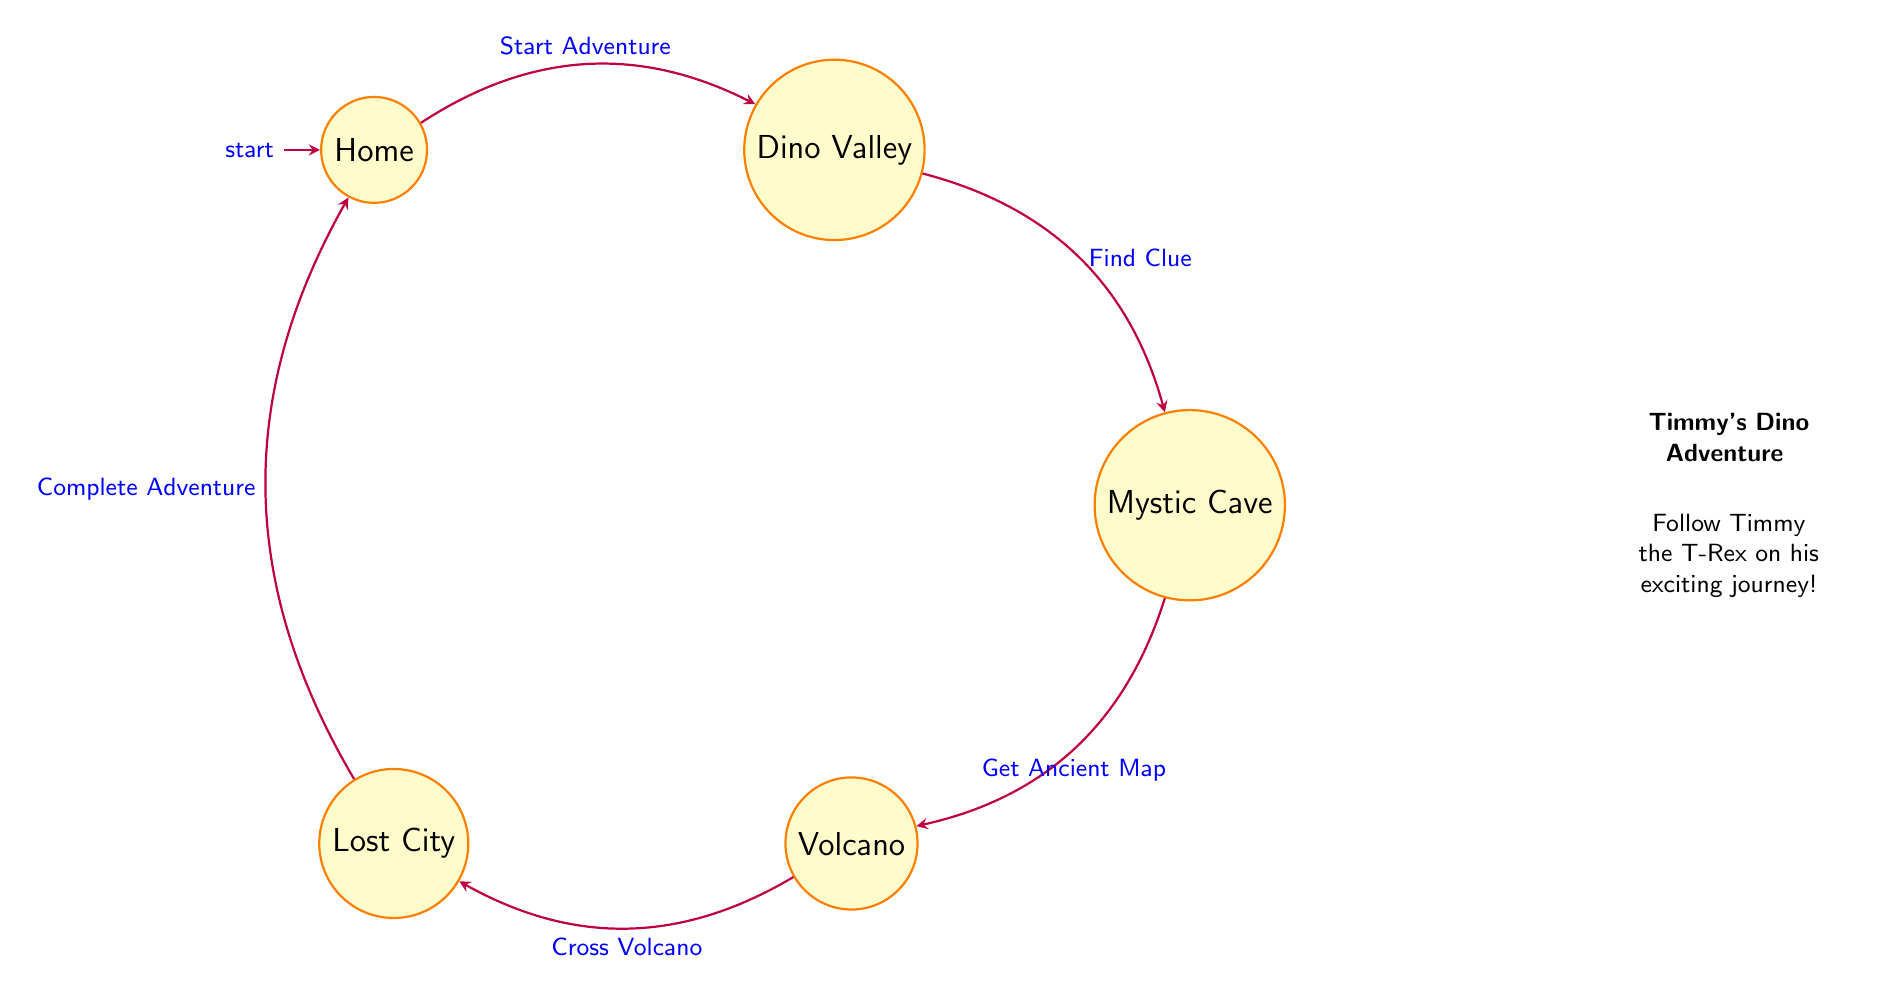What is the first state in Timmy's adventure? The diagram starts with the "Home" state as the initial node where the adventure begins.
Answer: Home How many states are in Timmy's adventure? By counting the nodes in the diagram, we find there are five states: Home, Dino Valley, Mystic Cave, Volcano, and Lost City.
Answer: 5 What action occurs when transitioning from Dino Valley? Looking at the transition from Dino Valley, the action "Find Clue" is listed as the trigger that leads to Mystic Cave.
Answer: Find Clue What is the final state in the adventure? The diagram shows that the last state before returning to the start (Home) is the Lost City.
Answer: Lost City What action must Timmy take to cross the Volcano? In the transition from the Volcano state, the action needed is "Cross Volcano" to proceed to Lost City.
Answer: Cross Volcano Which two states are directly connected by the action "Get Ancient Map"? The action connects Mystic Cave and Volcano, making them the two states related by that action.
Answer: Mystic Cave, Volcano How many transitions are there in total across the adventure? By counting the connections (arrows) between the states, we see there are four transitions: Home to Dino Valley, Dino Valley to Mystic Cave, Mystic Cave to Volcano, and Volcano to Lost City.
Answer: 4 What must happen after discovering the ruins in the Lost City? After the adventure in the Lost City, the transition shows that the action "Complete Adventure" must be completed to return to Home.
Answer: Complete Adventure What state follows the Mystic Cave? According to the diagram, after Mystic Cave, the next state is Volcano, as indicated by the transition "Get Ancient Map."
Answer: Volcano 